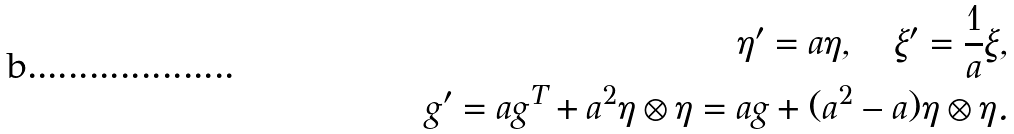Convert formula to latex. <formula><loc_0><loc_0><loc_500><loc_500>\eta ^ { \prime } = a \eta , \quad \xi ^ { \prime } = \frac { 1 } { a } \xi , \\ g ^ { \prime } = a g ^ { T } + a ^ { 2 } \eta \otimes \eta = a g + ( a ^ { 2 } - a ) \eta \otimes \eta . \\</formula> 